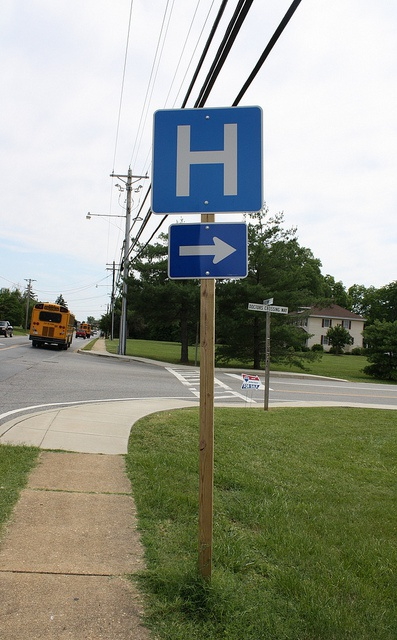Describe the objects in this image and their specific colors. I can see bus in white, black, brown, and maroon tones, car in white, black, gray, darkgray, and maroon tones, bus in white, black, maroon, and brown tones, and car in white, black, maroon, gray, and darkgray tones in this image. 